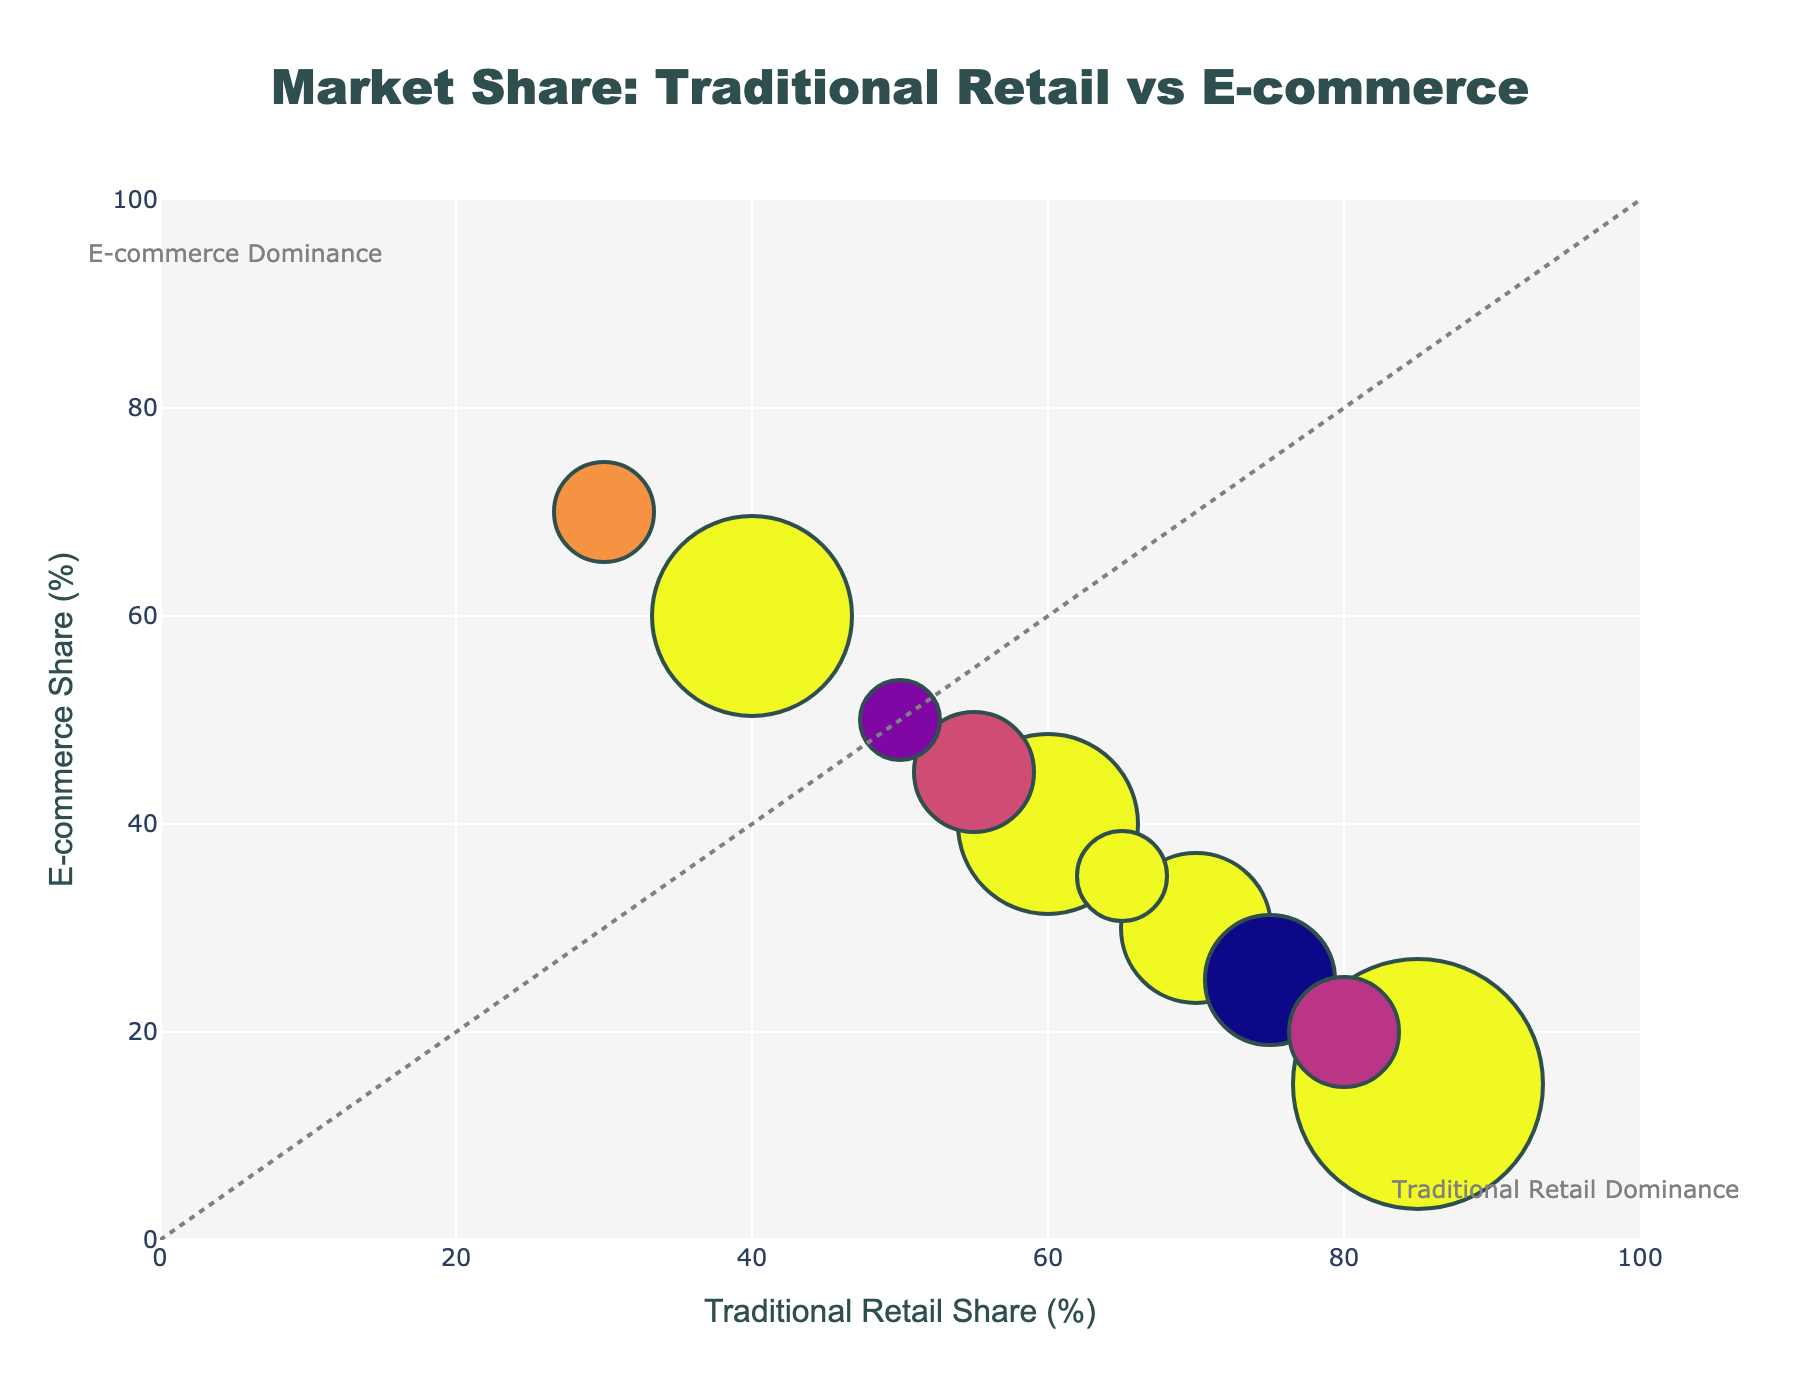What is the title of the figure? The title appears at the top of the figure, usually centered. In this case, it states the main subject of the plot
Answer: Market Share: Traditional Retail vs E-commerce What are the x-axis and y-axis titles? The x-axis title indicates what is measured horizontally, and the y-axis title indicates the vertical measurement. The x-axis shows 'Traditional Retail Share (%)' and the y-axis shows 'E-commerce Share (%)'
Answer: 'Traditional Retail Share (%)' and 'E-commerce Share (%)' How many categories have a higher traditional retail share than e-commerce share? Compare the position of each bubble. If it is to the right of the diagonal line, traditional retail has a higher share. There are 6 bubbles to the right of the diagonal line
Answer: 6 Which category has the smallest bubble size? The bubble size is proportional to the total market size. 'Toys' has the smallest bubble size, indicating its total market size is 80, the smallest in the data set
Answer: Toys Which category shows e-commerce dominance, and what is the e-commerce share percentage? E-commerce dominance is indicated by bubbles above the diagonal line with a higher e-commerce share percentage. 'Books' shows 70% in e-commerce share
Answer: Books, 70% What is the combined market size for categories with more than 50% e-commerce share? Identify the categories with more than 50% e-commerce share ('Clothing', 'Electronics', 'Books', 'Cosmetics') and sum their market sizes: 180 + 200 + 100 + 120 = 600
Answer: 600 Which category has the closest market share between traditional retail and e-commerce? Look for the bubble closest to the diagonal line of equality. 'Toys' has equal market shares with 50% each
Answer: Toys Which category has the largest traditional retail share and how large is its total market size? The largest traditional retail share is represented by the furthest right bubble. 'Groceries' has 85% traditional retail share with a market size of 250
Answer: Groceries, 250 Of the categories with more than 70% traditional retail share, which one has the smallest total market size? Filter categories with more than 70% traditional retail share ('Groceries', 'Furniture', 'Home Appliances', 'Jewelry'), then find the smallest market size which is for 'Jewelry' at 110
Answer: Jewelry, 110 